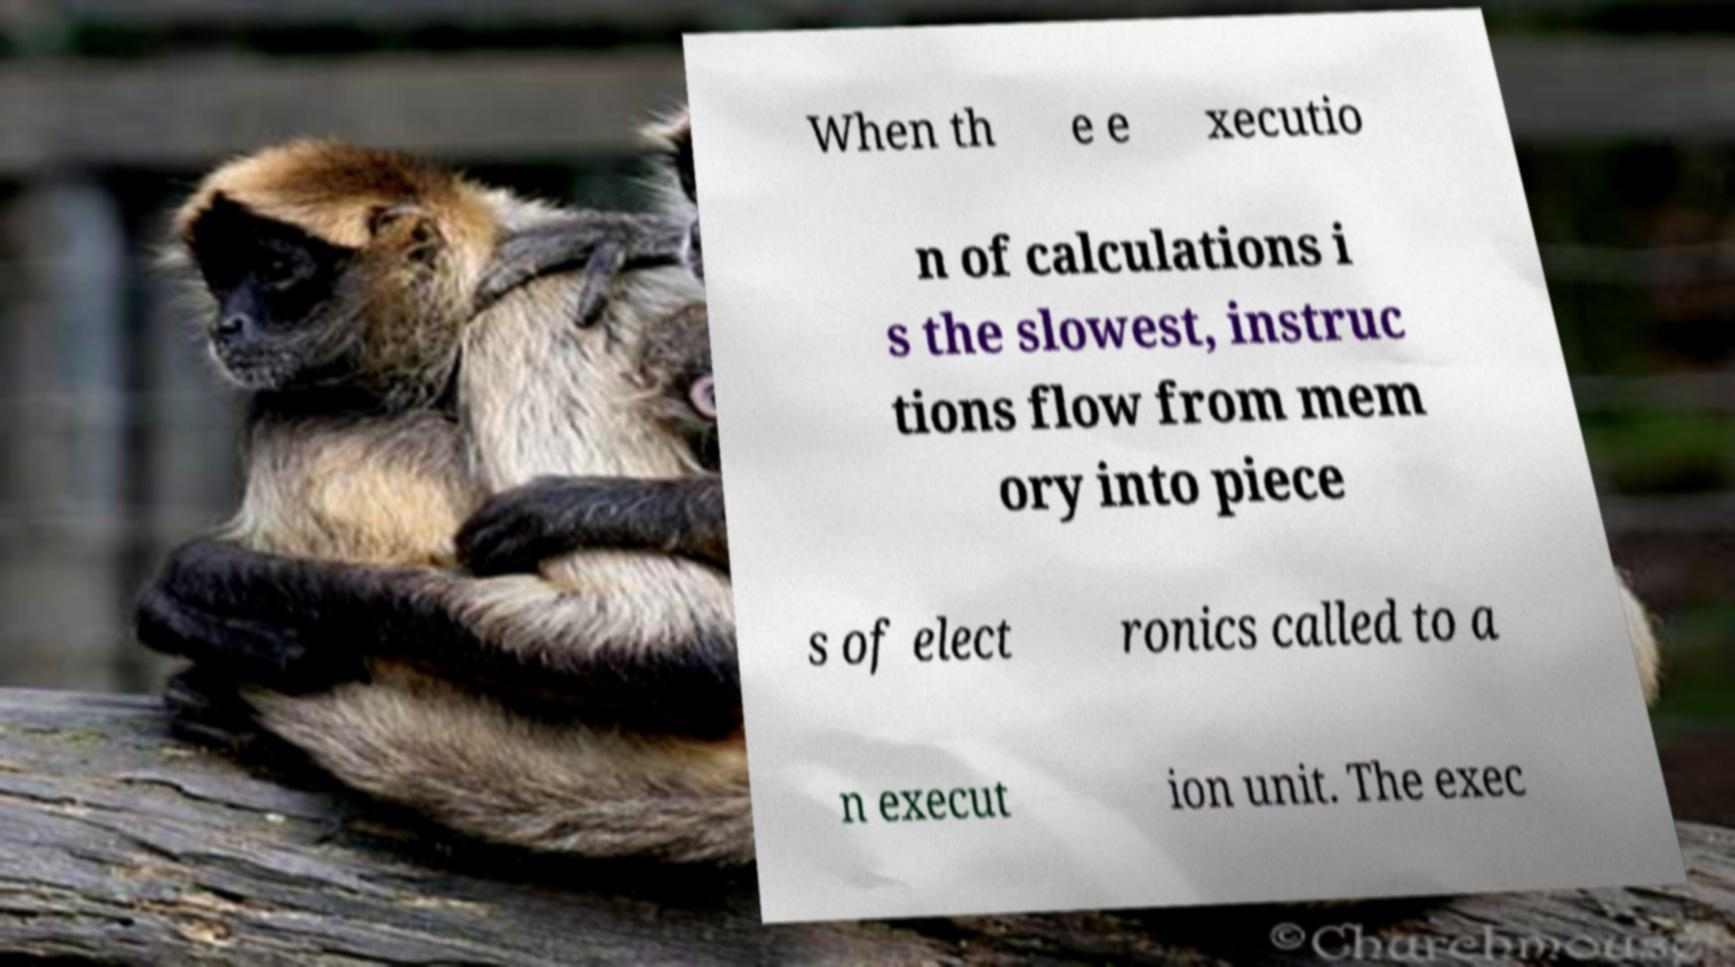What messages or text are displayed in this image? I need them in a readable, typed format. When th e e xecutio n of calculations i s the slowest, instruc tions flow from mem ory into piece s of elect ronics called to a n execut ion unit. The exec 